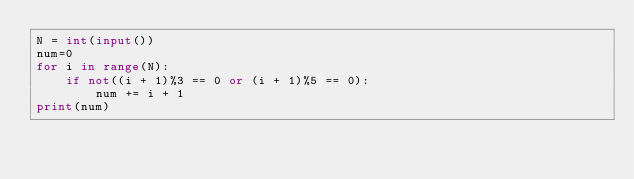<code> <loc_0><loc_0><loc_500><loc_500><_Python_>N = int(input())
num=0
for i in range(N):
    if not((i + 1)%3 == 0 or (i + 1)%5 == 0):
        num += i + 1
print(num)        </code> 